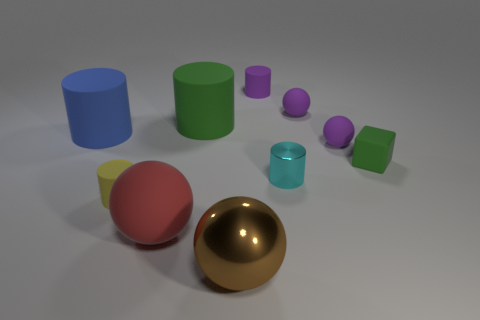Subtract 1 balls. How many balls are left? 3 Subtract all cyan shiny cylinders. How many cylinders are left? 4 Subtract all red cylinders. Subtract all yellow cubes. How many cylinders are left? 5 Subtract all cubes. How many objects are left? 9 Add 6 small purple spheres. How many small purple spheres are left? 8 Add 8 cyan things. How many cyan things exist? 9 Subtract 1 brown spheres. How many objects are left? 9 Subtract all tiny green matte blocks. Subtract all tiny yellow cylinders. How many objects are left? 8 